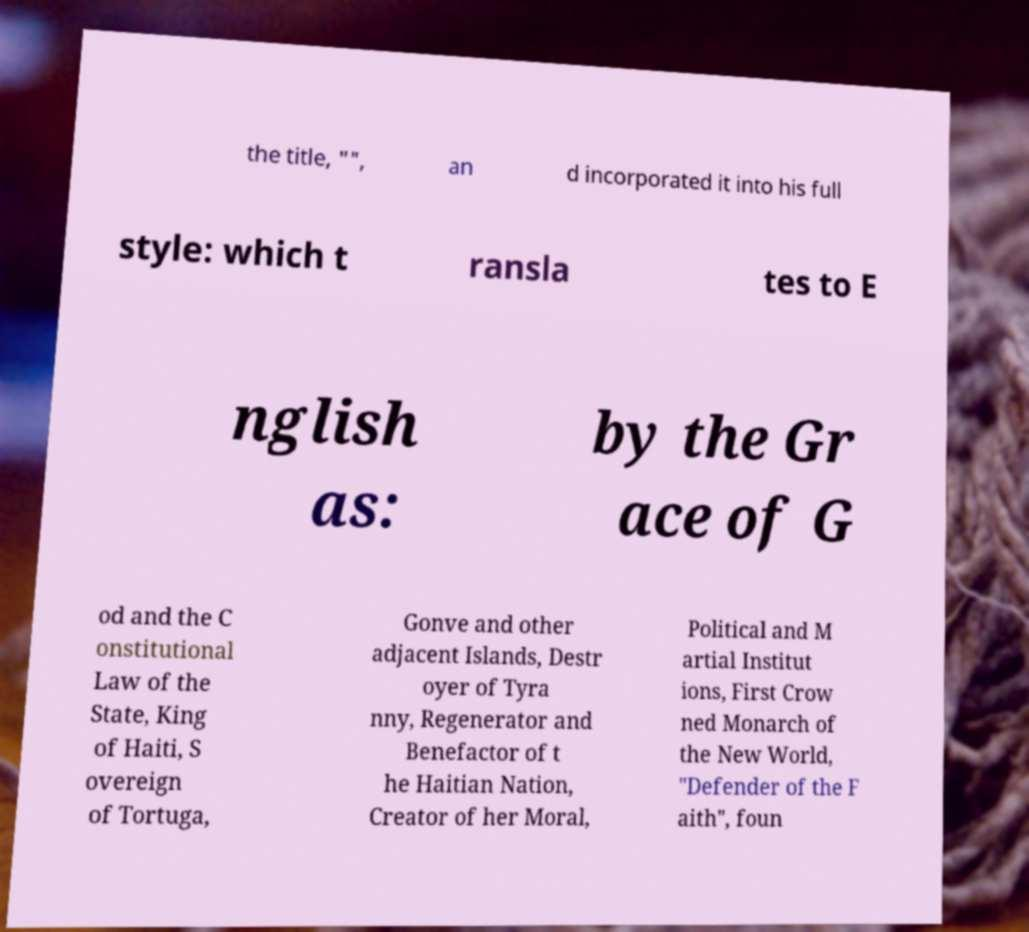Could you assist in decoding the text presented in this image and type it out clearly? the title, "", an d incorporated it into his full style: which t ransla tes to E nglish as: by the Gr ace of G od and the C onstitutional Law of the State, King of Haiti, S overeign of Tortuga, Gonve and other adjacent Islands, Destr oyer of Tyra nny, Regenerator and Benefactor of t he Haitian Nation, Creator of her Moral, Political and M artial Institut ions, First Crow ned Monarch of the New World, "Defender of the F aith", foun 